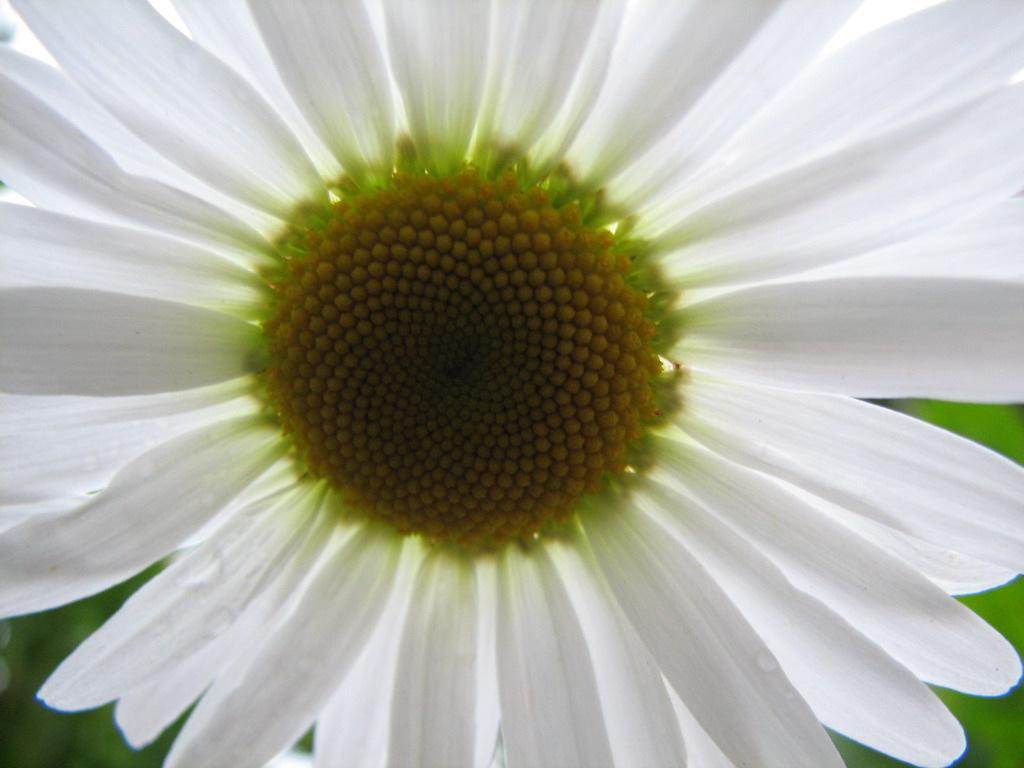What is the main subject of the image? There is a flower in the image. Can you describe the background of the image? The background of the image is blurred. What type of hope can be seen tangled in a cobweb in the image? There is no hope or cobweb present in the image; it features a flower with a blurred background. What appliance is visible in the image? There is no appliance present in the image. 